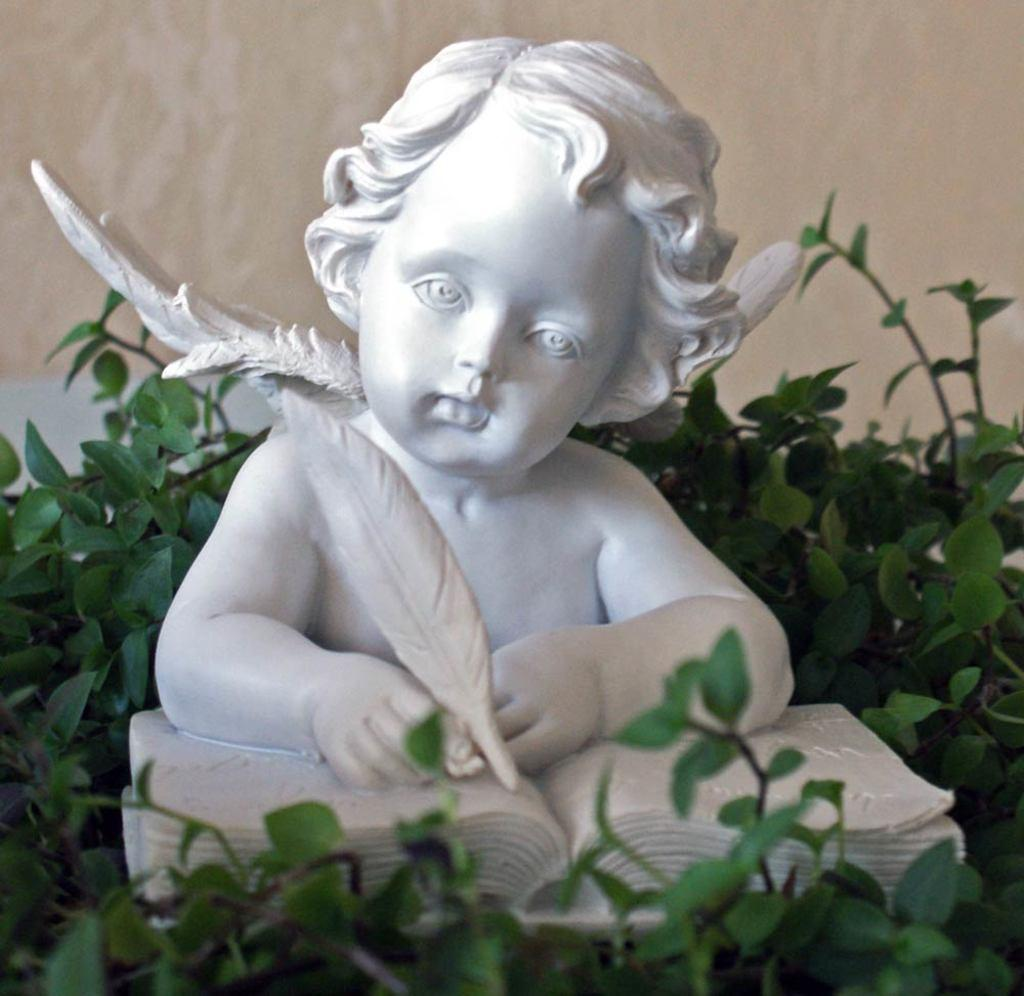What is the main subject in the center of the image? There is a statue in the center of the image. What can be seen in the background of the image? There are plants in the background of the image. What architectural feature is visible at the top of the image? There is a wall visible at the top of the image. What type of punishment is being carried out on the statue in the image? There is no punishment being carried out on the statue in the image; it is a stationary object. How many pizzas are visible on the statue in the image? There are no pizzas present in the image, as it features a statue and plants in the background. What type of cushion is placed on the statue in the image? There is no cushion present on the statue in the image. 